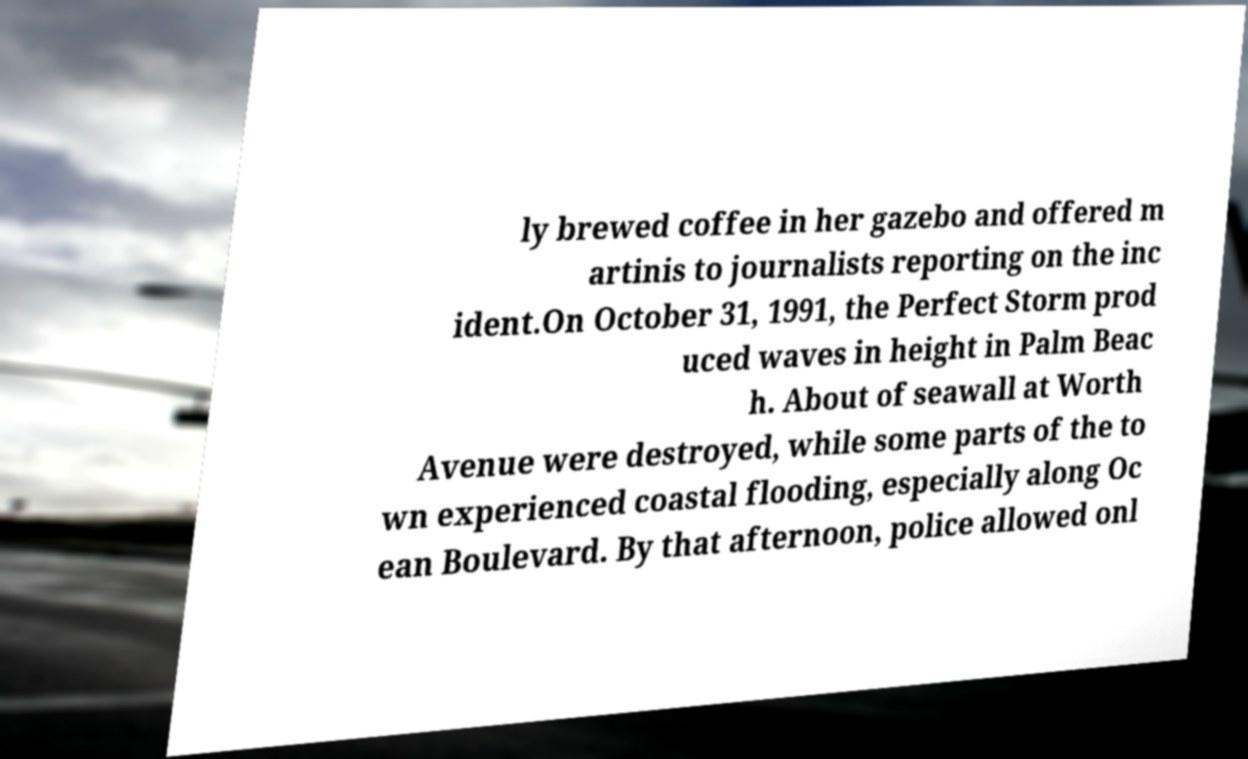Please identify and transcribe the text found in this image. ly brewed coffee in her gazebo and offered m artinis to journalists reporting on the inc ident.On October 31, 1991, the Perfect Storm prod uced waves in height in Palm Beac h. About of seawall at Worth Avenue were destroyed, while some parts of the to wn experienced coastal flooding, especially along Oc ean Boulevard. By that afternoon, police allowed onl 